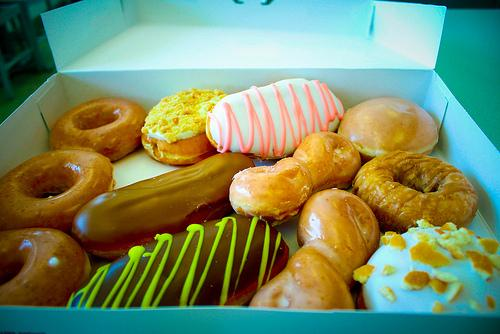Is the doughnut box open, and what color is it? Yes, the doughnut box is open, with coordinates 26 X and 2 Y, and it is white in color. Debate whether there is sufficient light on the box of donuts or not. There appears to be ample light on the box of donuts, as evident by the light at 157 X and 33 Y covering a 139x139 area. Mention the filling hole in one of the donuts and where it is located. There's a filling hole in the side of a doughnut at 144 X and 137 Y, with a size of 31x31. Identify the primary object on the table and describe its features. A box of assorted donuts sits on the table; the donuts come in various glazes, frostings and toppings. Describe the contents of a plain sugar-glazed donut in the box. A round sugar glazed donut is located at 49 X and 95 Y coordinates, with dimensions of 95x95. Tell me about the long brown donut with reference to its position and characteristics. A long brown glazed donut is located at 80 X and 146 Y coordinates; it has yellow drizzle on top and is placed in the white donut box. Express the status of the donut box and its contents. The donut box is open, revealing a delightful assortment of glazed, frosted, and topped donuts inside. What kind of surface is under the donut box, and what is its color? A gray table surface lies beneath the donut box at 450 X and 10 Y, spanning a 49x49 area. In your own words, point out the most appealing donut in the white box. The donut with a pink and white glaze looks particularly tempting and delicious. Provide information about the assorted doughnuts in the white box and their positioning. A collection of assorted doughnuts is placed in a white box at coordinates 17 X and 77 Y, with dimensions of 482x482. 